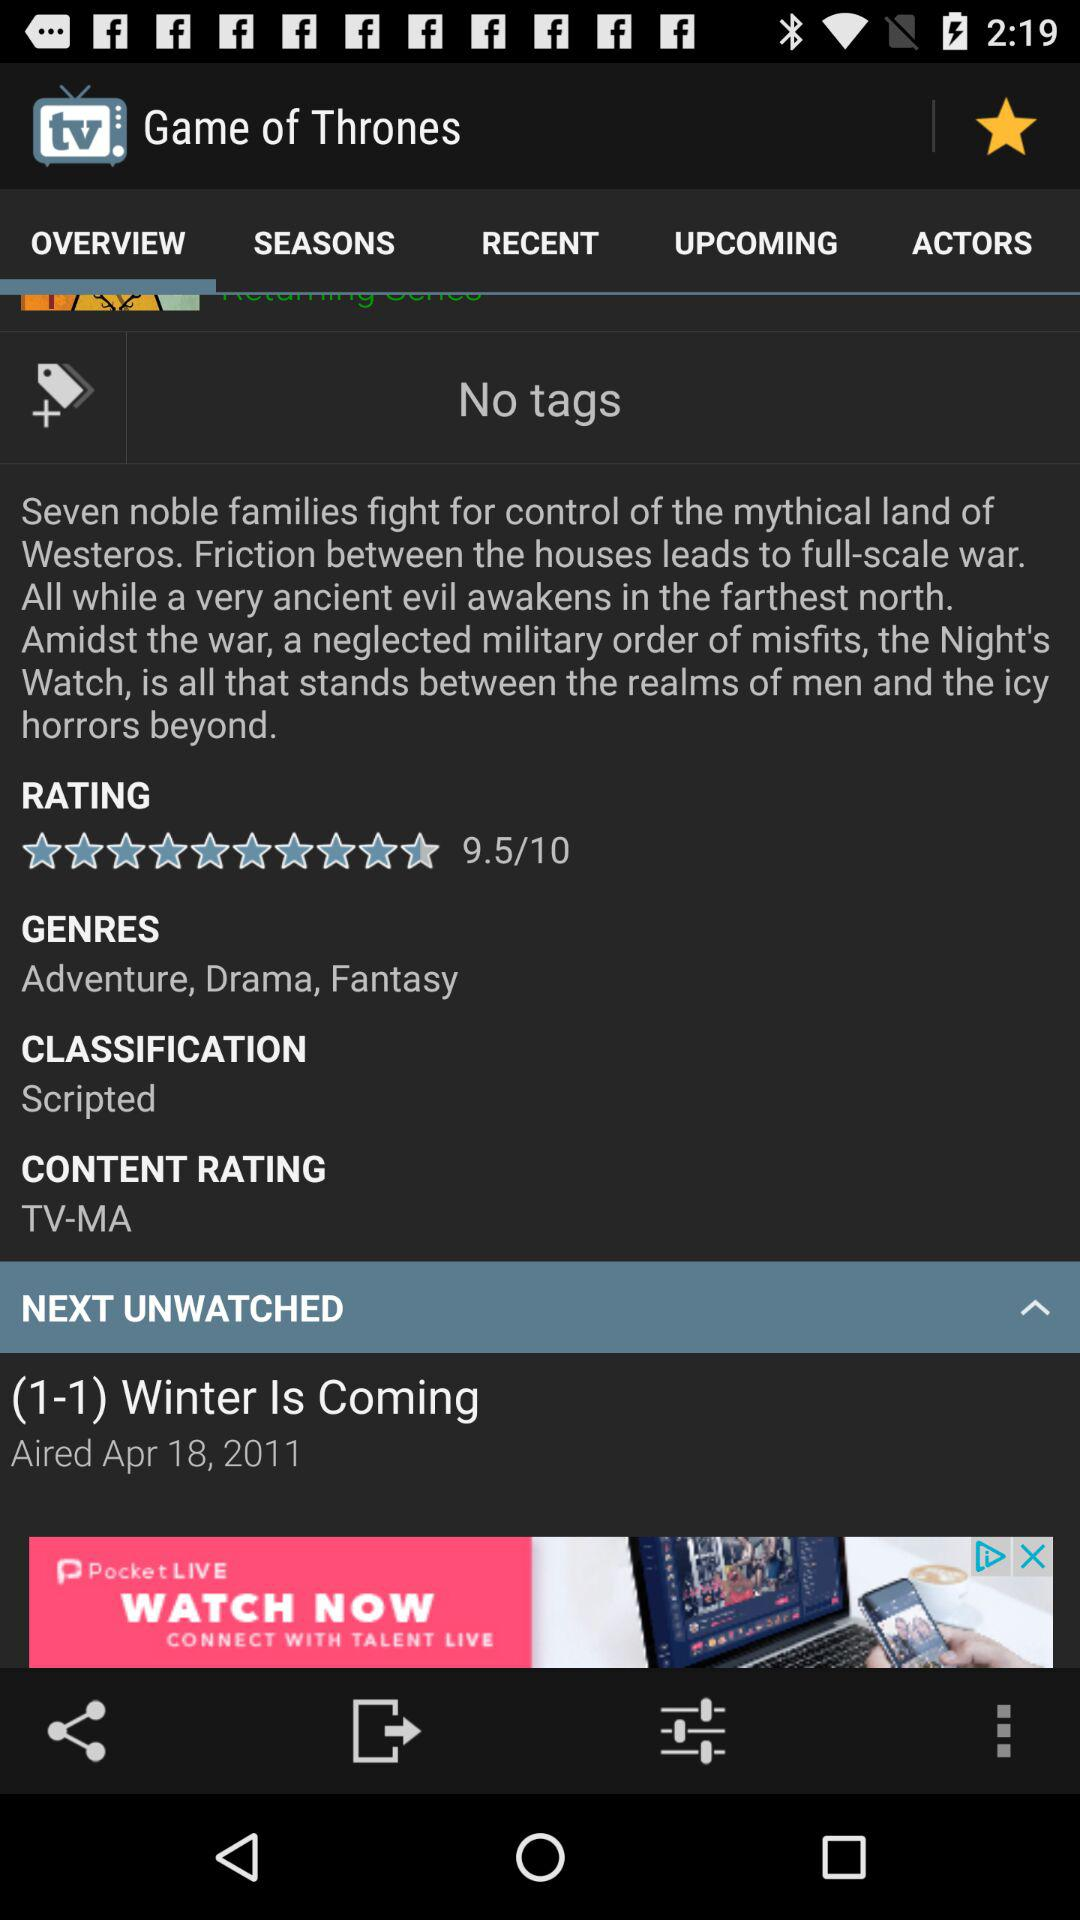How many seasons of "GAME OF THRONES" are there?
When the provided information is insufficient, respond with <no answer>. <no answer> 